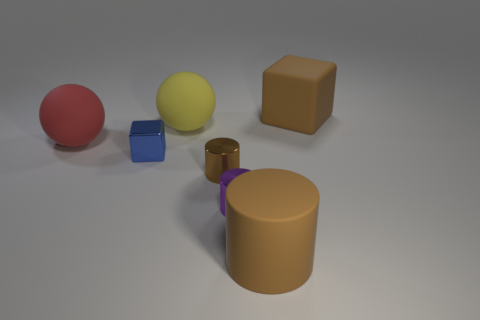Is the number of purple objects that are left of the purple metallic object greater than the number of tiny cylinders on the right side of the tiny blue cube?
Offer a very short reply. No. What number of yellow matte balls are in front of the rubber sphere that is on the right side of the big red rubber thing?
Provide a succinct answer. 0. Are there any big balls of the same color as the big cube?
Ensure brevity in your answer.  No. Is the size of the brown metal object the same as the blue metal cube?
Offer a very short reply. Yes. Do the matte block and the metallic cube have the same color?
Your answer should be very brief. No. The thing that is to the right of the rubber object that is in front of the tiny blue shiny thing is made of what material?
Offer a terse response. Rubber. What material is the big yellow object that is the same shape as the red rubber thing?
Keep it short and to the point. Rubber. Does the cube that is behind the red ball have the same size as the big yellow ball?
Keep it short and to the point. Yes. What number of rubber objects are either brown objects or purple cylinders?
Give a very brief answer. 2. What is the thing that is in front of the red thing and behind the small brown cylinder made of?
Make the answer very short. Metal. 